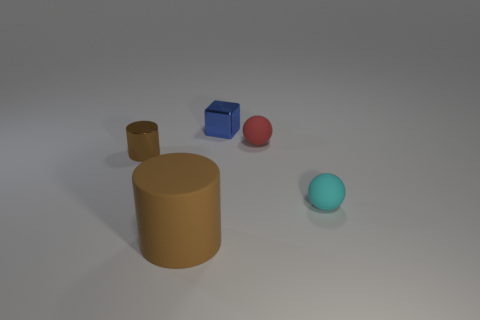Is there anything else that is the same size as the cyan thing?
Provide a succinct answer. Yes. Do the matte thing in front of the cyan thing and the small matte object that is behind the tiny metallic cylinder have the same shape?
Your answer should be compact. No. Are there fewer big cylinders behind the blue thing than brown matte cylinders that are behind the tiny brown object?
Offer a terse response. No. What number of other things are the same shape as the red matte thing?
Your answer should be compact. 1. What is the shape of the large thing that is the same material as the cyan sphere?
Provide a succinct answer. Cylinder. The object that is both to the left of the cyan matte ball and in front of the small brown metal thing is what color?
Offer a terse response. Brown. Is the material of the small blue block left of the red rubber ball the same as the tiny cyan sphere?
Give a very brief answer. No. Is the number of big brown things that are behind the tiny cyan rubber sphere less than the number of small cyan matte cylinders?
Offer a very short reply. No. Are there any big blue spheres made of the same material as the big brown cylinder?
Offer a very short reply. No. Is the size of the red ball the same as the metal thing that is to the left of the small blue thing?
Give a very brief answer. Yes. 